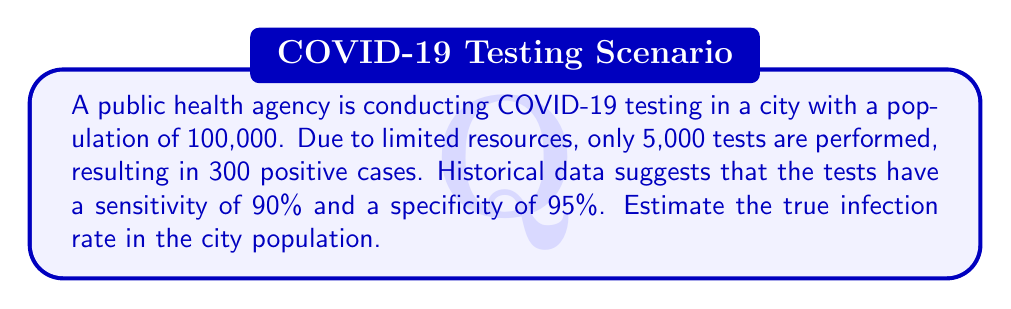Give your solution to this math problem. Let's approach this step-by-step using Bayes' theorem and the given information:

1) Define variables:
   $P(I)$ = true infection rate (what we want to estimate)
   $P(T+|I)$ = sensitivity = 0.90
   $P(T-|NI)$ = specificity = 0.95
   $P(T+)$ = proportion of positive tests = 300/5000 = 0.06

2) Use Bayes' theorem:
   $$P(I|T+) = \frac{P(T+|I) \cdot P(I)}{P(T+)}$$

3) Express $P(T+)$ in terms of $P(I)$:
   $$P(T+) = P(T+|I) \cdot P(I) + P(T+|NI) \cdot (1-P(I))$$
   $$0.06 = 0.90 \cdot P(I) + (1-0.95) \cdot (1-P(I))$$
   $$0.06 = 0.90 \cdot P(I) + 0.05 \cdot (1-P(I))$$

4) Solve for $P(I)$:
   $$0.06 = 0.90P(I) + 0.05 - 0.05P(I)$$
   $$0.01 = 0.85P(I)$$
   $$P(I) = \frac{0.01}{0.85} \approx 0.0118$$

5) Convert to percentage:
   True infection rate ≈ 1.18%

6) Estimate total infections in the city:
   $100,000 \cdot 0.0118 = 1,180$ infected individuals
Answer: 1.18% 